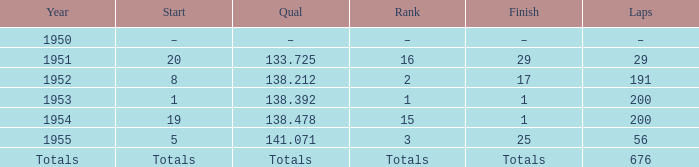What rating had an initial placement of 19? 15.0. 